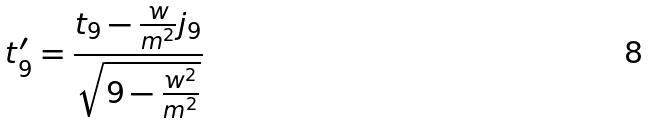Convert formula to latex. <formula><loc_0><loc_0><loc_500><loc_500>t _ { 9 } ^ { \prime } = \frac { t _ { 9 } - \frac { w } { m ^ { 2 } } j _ { 9 } } { \sqrt { 9 - \frac { w ^ { 2 } } { m ^ { 2 } } } }</formula> 